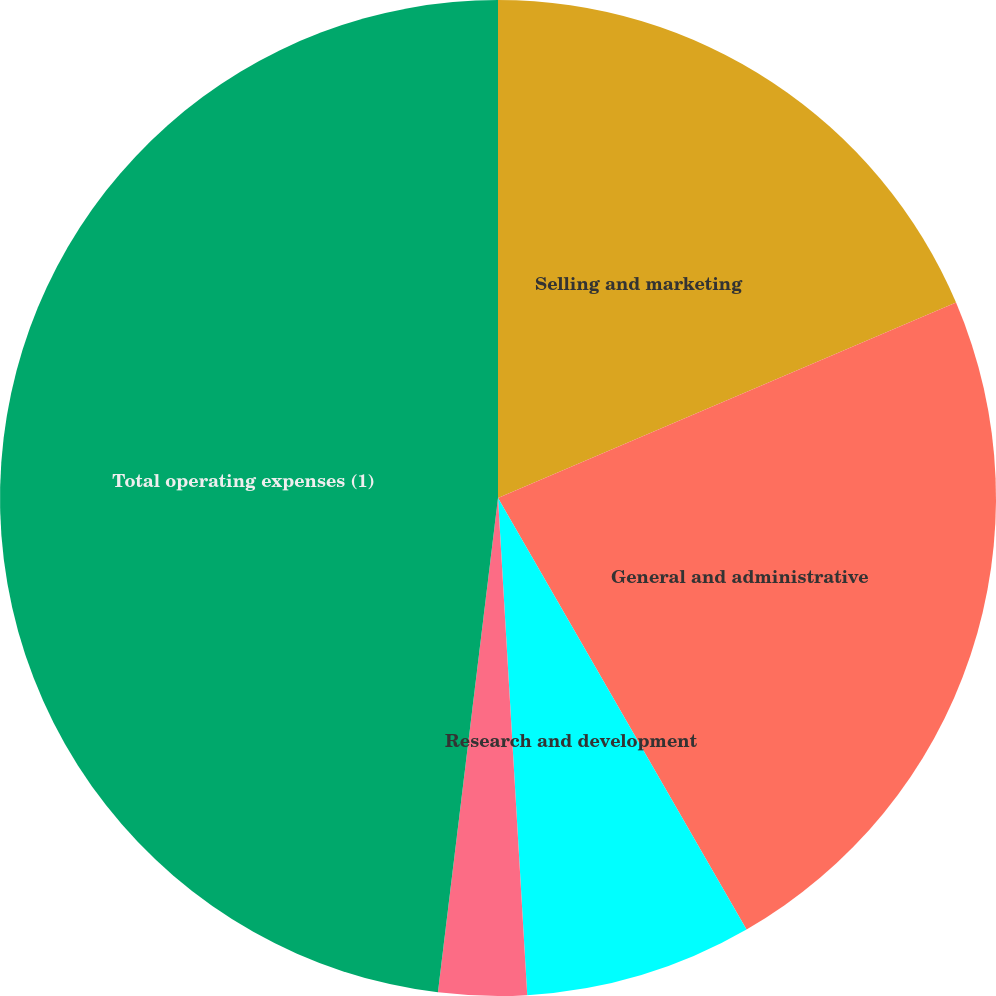Convert chart. <chart><loc_0><loc_0><loc_500><loc_500><pie_chart><fcel>Selling and marketing<fcel>General and administrative<fcel>Research and development<fcel>Depreciation and amortization<fcel>Total operating expenses (1)<nl><fcel>18.58%<fcel>23.1%<fcel>7.38%<fcel>2.86%<fcel>48.07%<nl></chart> 